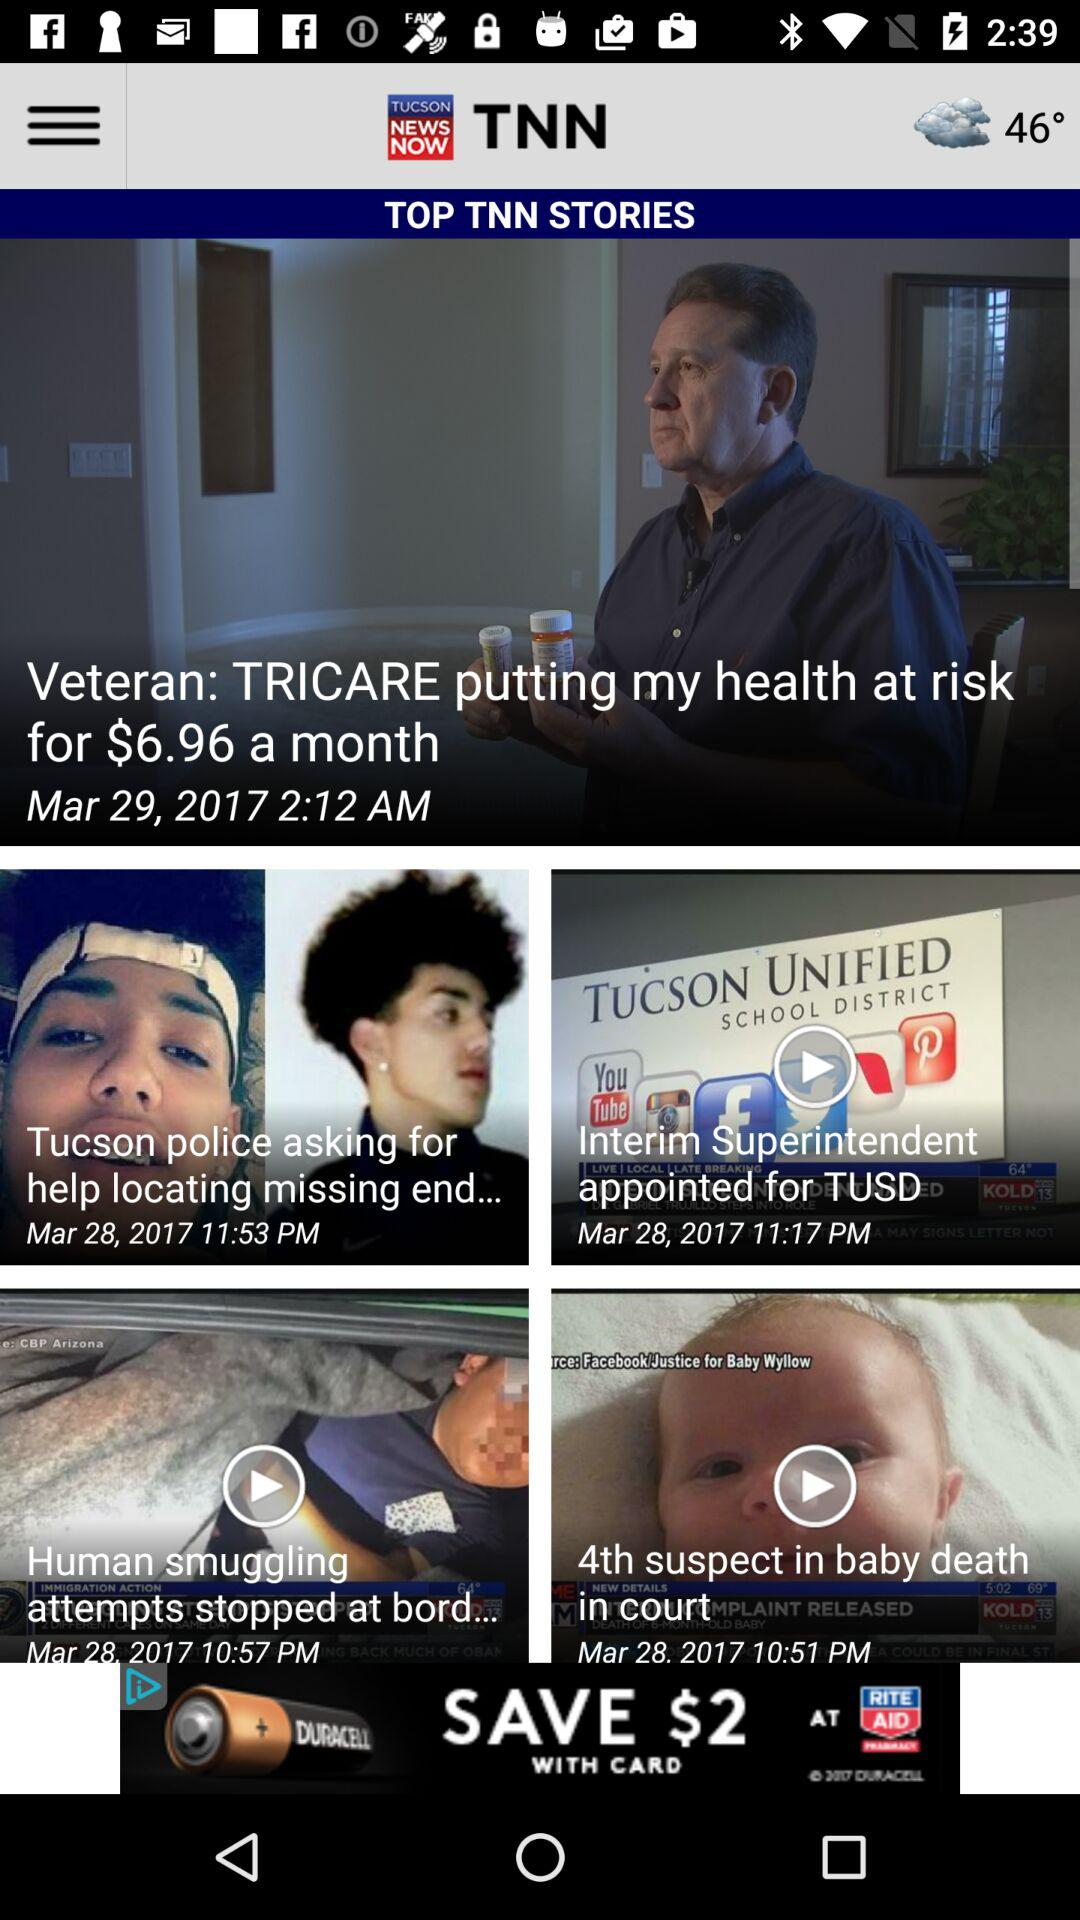What is the posted time of the "Interim Superintendent appointed for TUSD" news? The posted time of the "Interim Superintendent appointed for TUSD" news is 11:17 p.m. 